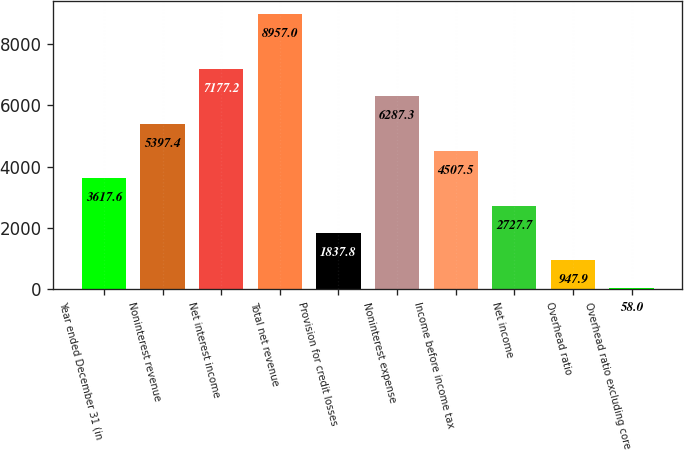Convert chart. <chart><loc_0><loc_0><loc_500><loc_500><bar_chart><fcel>Year ended December 31 (in<fcel>Noninterest revenue<fcel>Net interest income<fcel>Total net revenue<fcel>Provision for credit losses<fcel>Noninterest expense<fcel>Income before income tax<fcel>Net income<fcel>Overhead ratio<fcel>Overhead ratio excluding core<nl><fcel>3617.6<fcel>5397.4<fcel>7177.2<fcel>8957<fcel>1837.8<fcel>6287.3<fcel>4507.5<fcel>2727.7<fcel>947.9<fcel>58<nl></chart> 